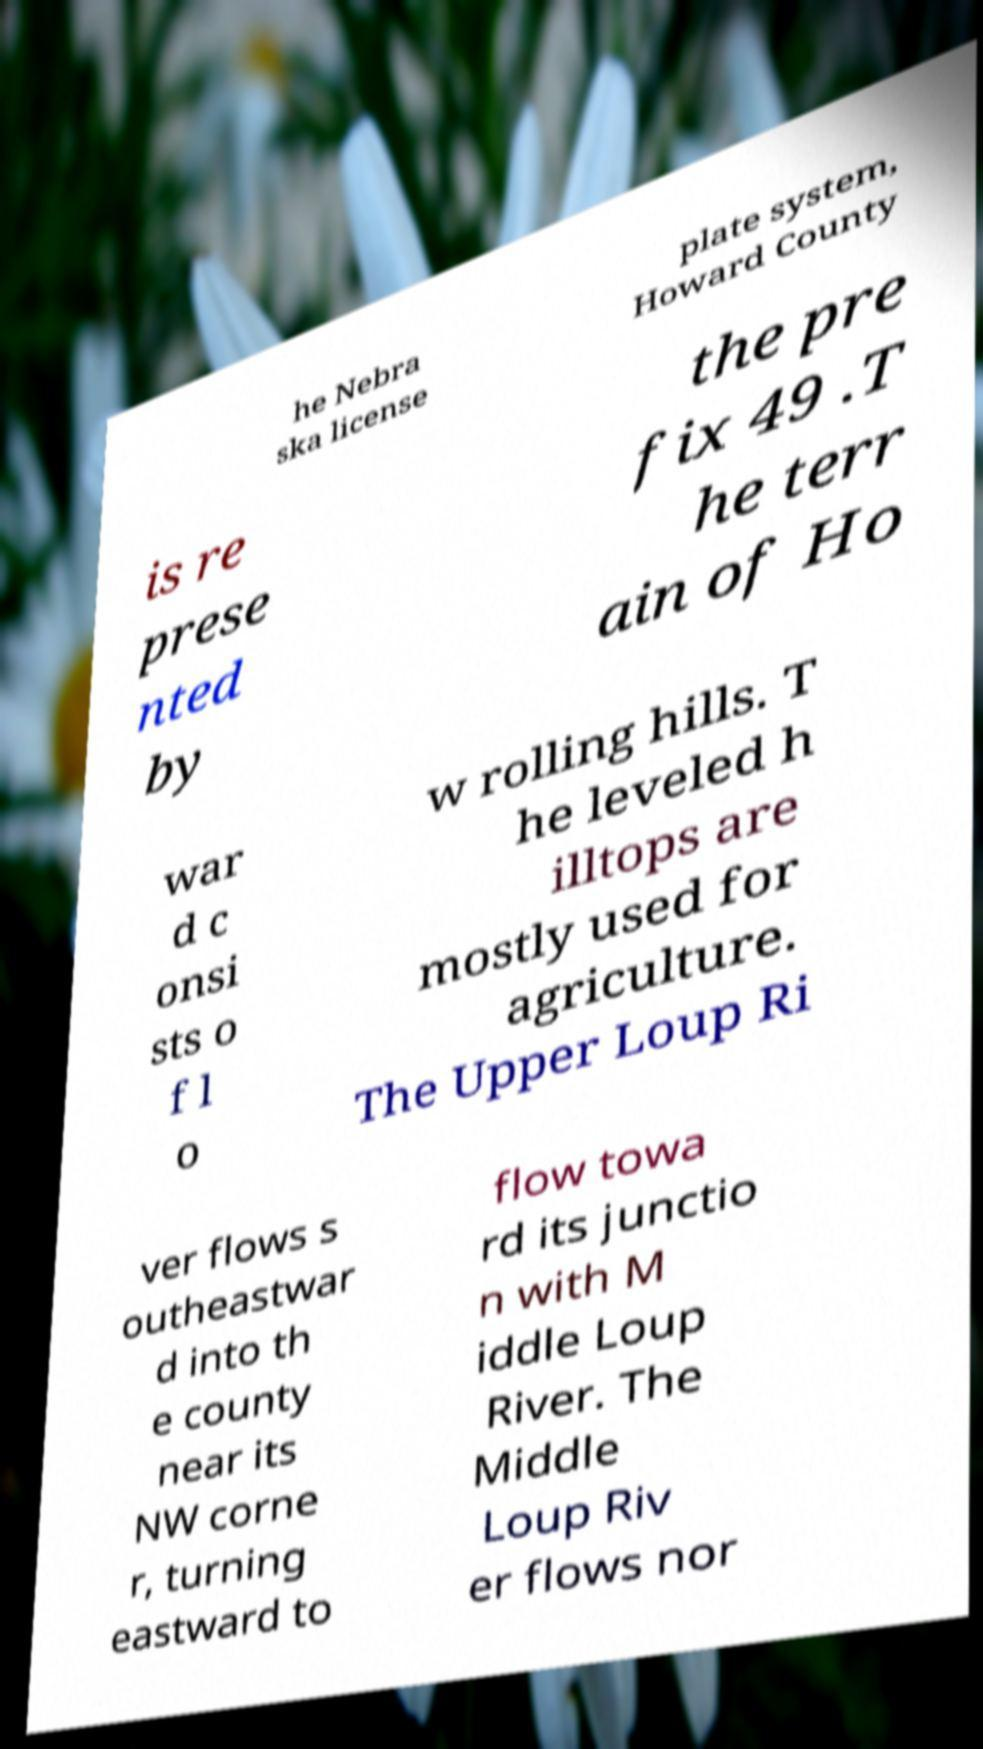Could you extract and type out the text from this image? he Nebra ska license plate system, Howard County is re prese nted by the pre fix 49 .T he terr ain of Ho war d c onsi sts o f l o w rolling hills. T he leveled h illtops are mostly used for agriculture. The Upper Loup Ri ver flows s outheastwar d into th e county near its NW corne r, turning eastward to flow towa rd its junctio n with M iddle Loup River. The Middle Loup Riv er flows nor 